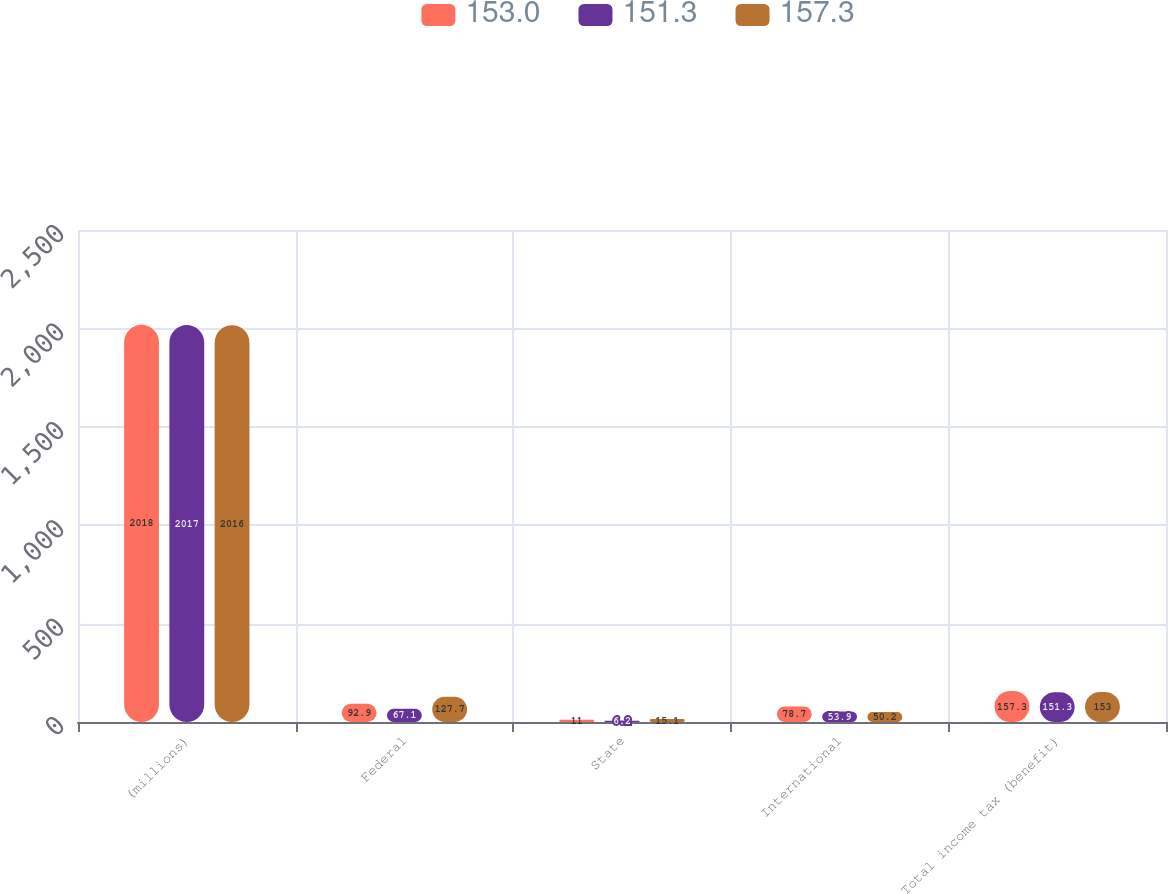Convert chart. <chart><loc_0><loc_0><loc_500><loc_500><stacked_bar_chart><ecel><fcel>(millions)<fcel>Federal<fcel>State<fcel>International<fcel>Total income tax (benefit)<nl><fcel>153<fcel>2018<fcel>92.9<fcel>11<fcel>78.7<fcel>157.3<nl><fcel>151.3<fcel>2017<fcel>67.1<fcel>6.2<fcel>53.9<fcel>151.3<nl><fcel>157.3<fcel>2016<fcel>127.7<fcel>15.1<fcel>50.2<fcel>153<nl></chart> 